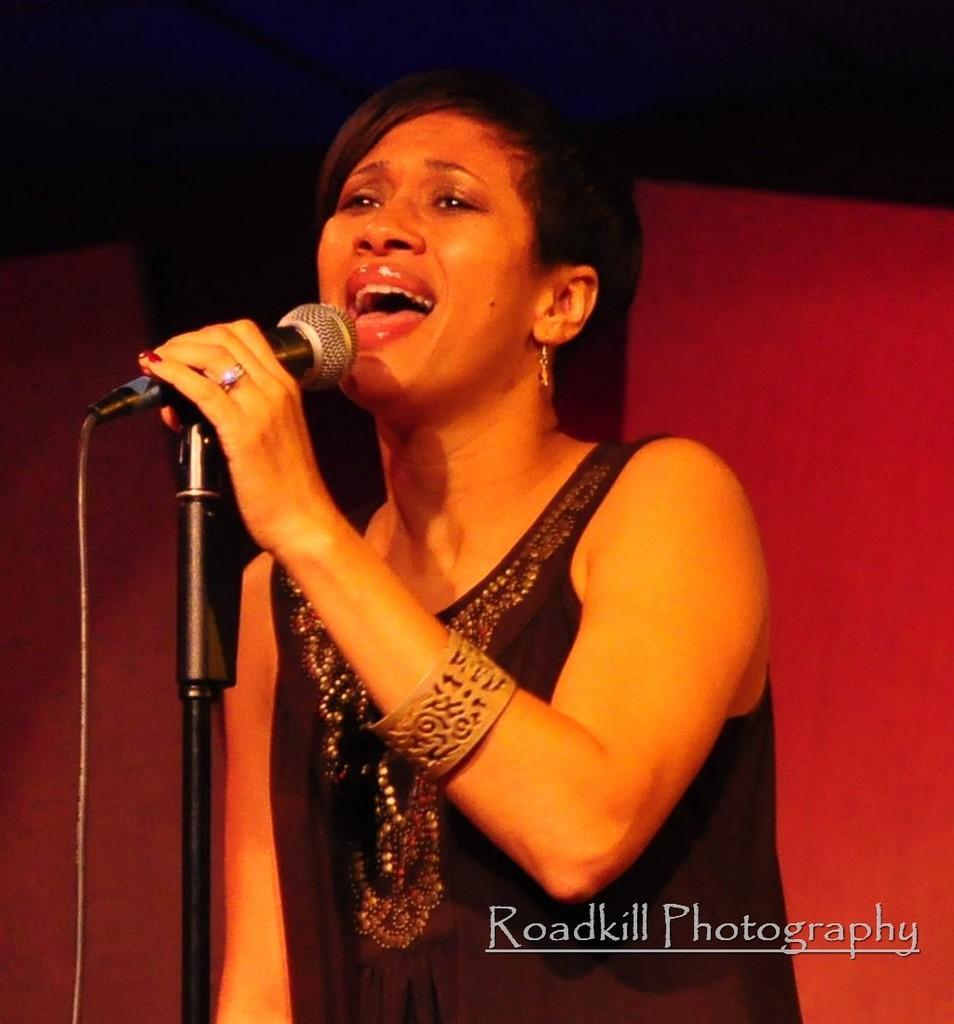How would you summarize this image in a sentence or two? Here we can see a woman singing in the microphone present in front of her 